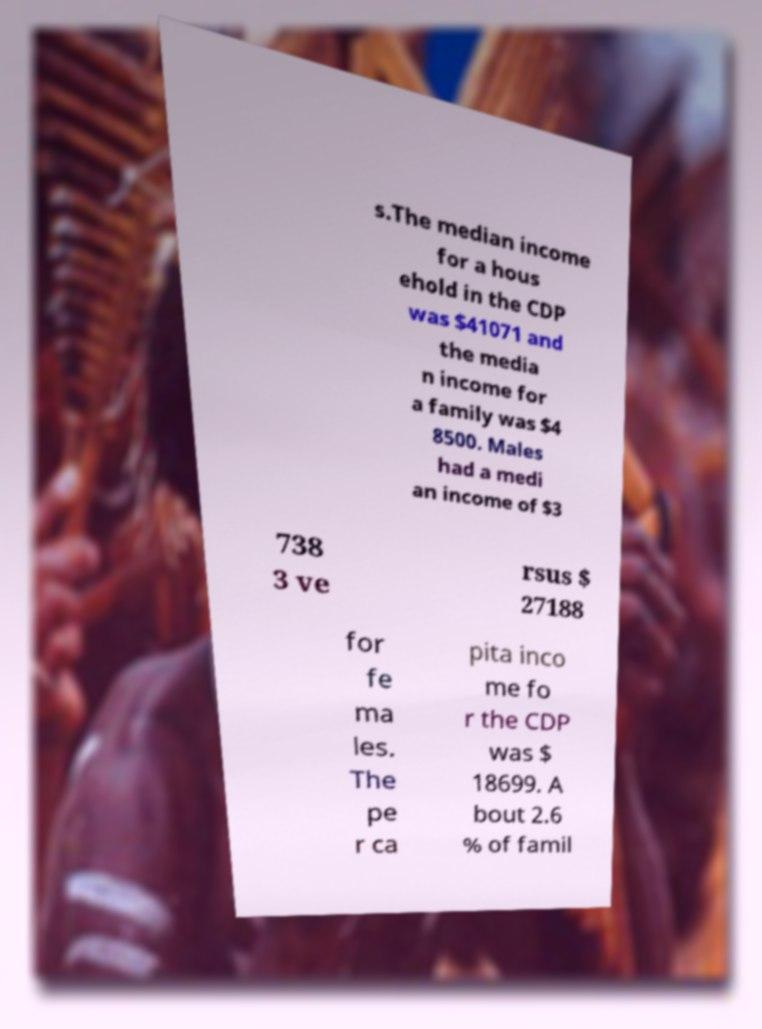Can you read and provide the text displayed in the image?This photo seems to have some interesting text. Can you extract and type it out for me? s.The median income for a hous ehold in the CDP was $41071 and the media n income for a family was $4 8500. Males had a medi an income of $3 738 3 ve rsus $ 27188 for fe ma les. The pe r ca pita inco me fo r the CDP was $ 18699. A bout 2.6 % of famil 